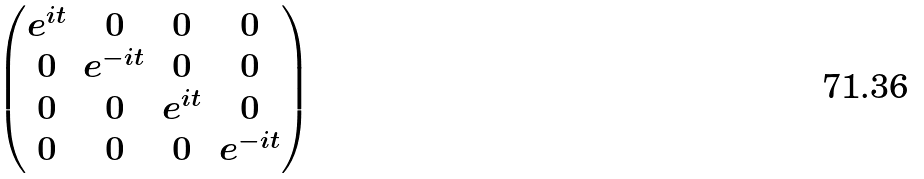Convert formula to latex. <formula><loc_0><loc_0><loc_500><loc_500>\begin{pmatrix} e ^ { i t } & 0 & 0 & 0 \\ 0 & e ^ { - i t } & 0 & 0 \\ 0 & 0 & e ^ { i t } & 0 \\ 0 & 0 & 0 & e ^ { - i t } \end{pmatrix}</formula> 